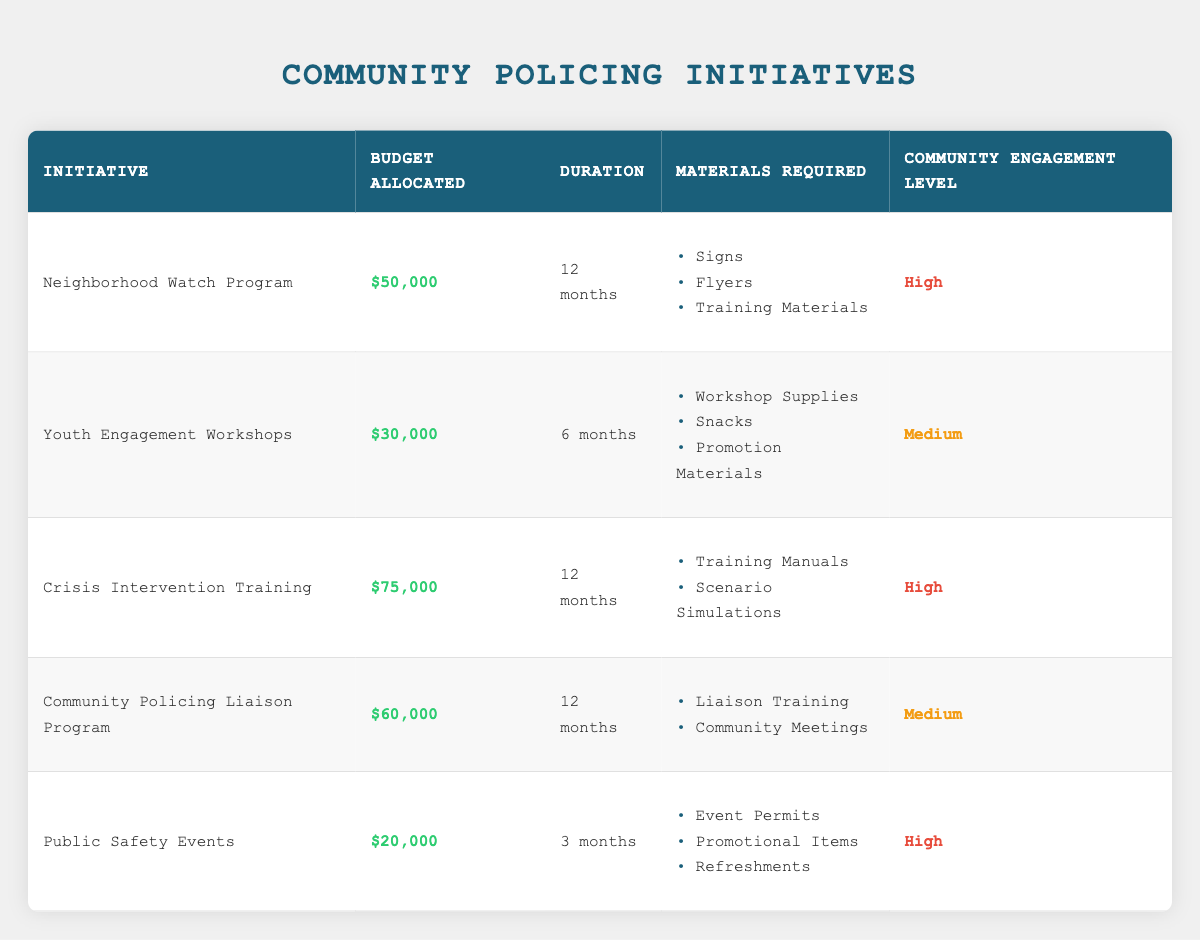What is the budget allocated for the Youth Engagement Workshops? The budget for the Youth Engagement Workshops is provided in the table under the "Budget Allocated" column for that initiative. It is listed as $30,000.
Answer: $30,000 Which initiative has the highest budget? To find this, I look through the "Budget Allocated" column and identify that the Crisis Intervention Training with a budget of $75,000 has the highest value compared to the other initiatives.
Answer: Crisis Intervention Training What is the total budget allocated for all initiatives? I sum the budget amounts of all initiatives: $50,000 + $30,000 + $75,000 + $60,000 + $20,000 = $235,000. The total signifies the overall financial commitment to community policing.
Answer: $235,000 Is the duration of the Public Safety Events longer than that of the Youth Engagement Workshops? The duration of Public Safety Events is listed as 3 months, while the Youth Engagement Workshops have a duration of 6 months. Therefore, 3 months is not longer than 6 months.
Answer: No How many initiatives have a high level of community engagement? I check the "Community Engagement Level" column and count the initiatives labeled with "High." The initiatives Neighborhood Watch Program, Crisis Intervention Training, and Public Safety Events all have this classification, totaling three.
Answer: 3 What can be inferred about the materials required for the Neighborhood Watch Program compared to the Community Policing Liaison Program? I note the specific materials listed for both: The Neighborhood Watch Program requires signs, flyers, and training materials, while the Community Policing Liaison Program needs liaison training and community meetings. It suggests that the Neighborhood Watch Program focuses more on communication and awareness tools, while the Liaison Program is about formal training and facilitation.
Answer: The Neighborhood Watch focuses on awareness tools; the Liaison Program on formal training What is the average budget allocated across all initiatives? To calculate the average, I first sum all budgets ($235,000) and then divide by the number of initiatives (5): $235,000 / 5 = $47,000. This gives the average amount spent on community policing initiatives.
Answer: $47,000 Are there any initiatives under 6 months duration? I check the "Duration" column to see if any initiative is under 6 months. The Public Safety Events are for 3 months, which is less than 6 months. Thus, there is at least one initiative with a shorter duration.
Answer: Yes Which initiatives require training materials? I look through the "Materials Required" for all initiatives. The Neighborhood Watch Program and Crisis Intervention Training both list training materials, indicating a need for knowledge transfer and skill development in these programs.
Answer: Neighborhood Watch Program, Crisis Intervention Training 